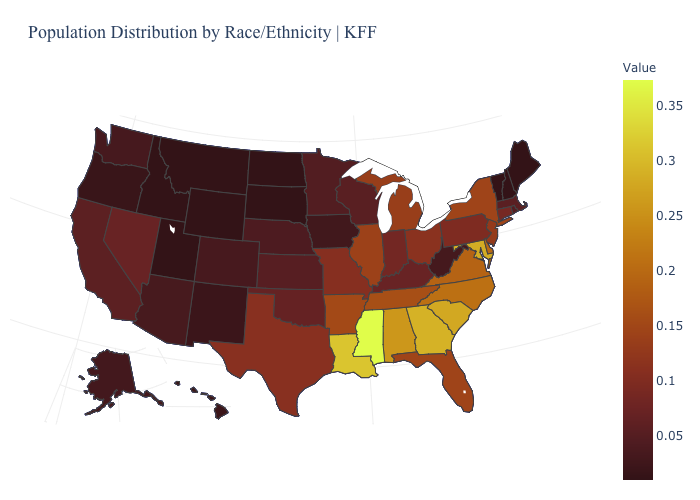Among the states that border North Dakota , which have the lowest value?
Give a very brief answer. Montana, South Dakota. Which states hav the highest value in the South?
Quick response, please. Mississippi. Does New York have the highest value in the Northeast?
Concise answer only. Yes. Among the states that border Missouri , which have the highest value?
Short answer required. Tennessee. 